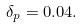<formula> <loc_0><loc_0><loc_500><loc_500>\delta _ { p } = 0 . 0 4 .</formula> 